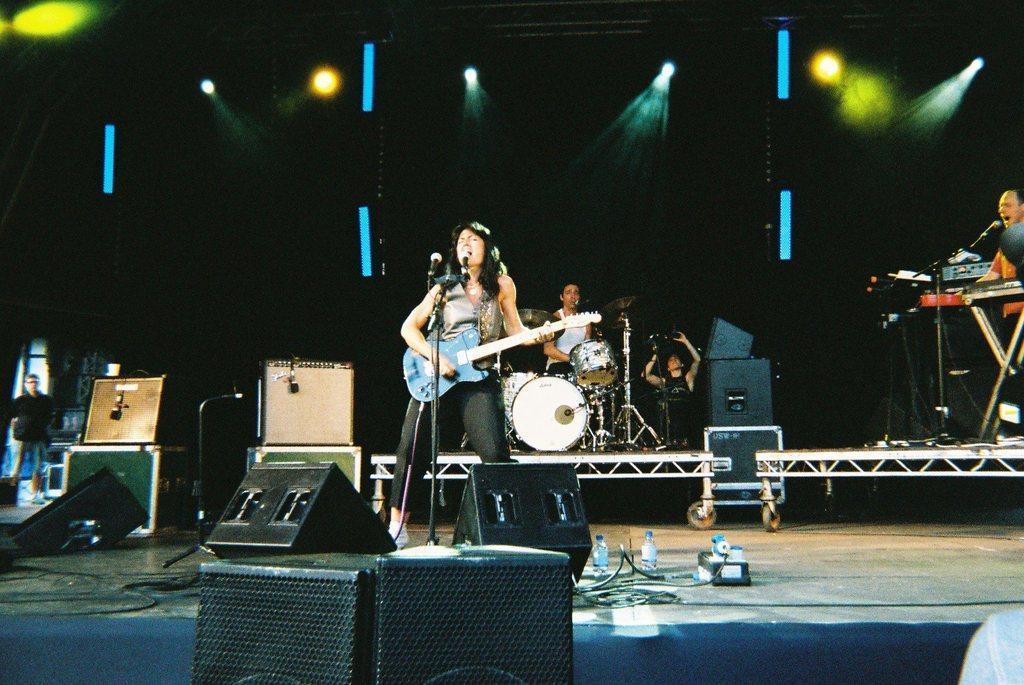Could you give a brief overview of what you see in this image? In this image there are a few people playing musical instruments on the stage, on the stage there are few objects, speakers, bottles, lights attached to the roof and a person standing near the window. 